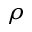<formula> <loc_0><loc_0><loc_500><loc_500>\rho</formula> 